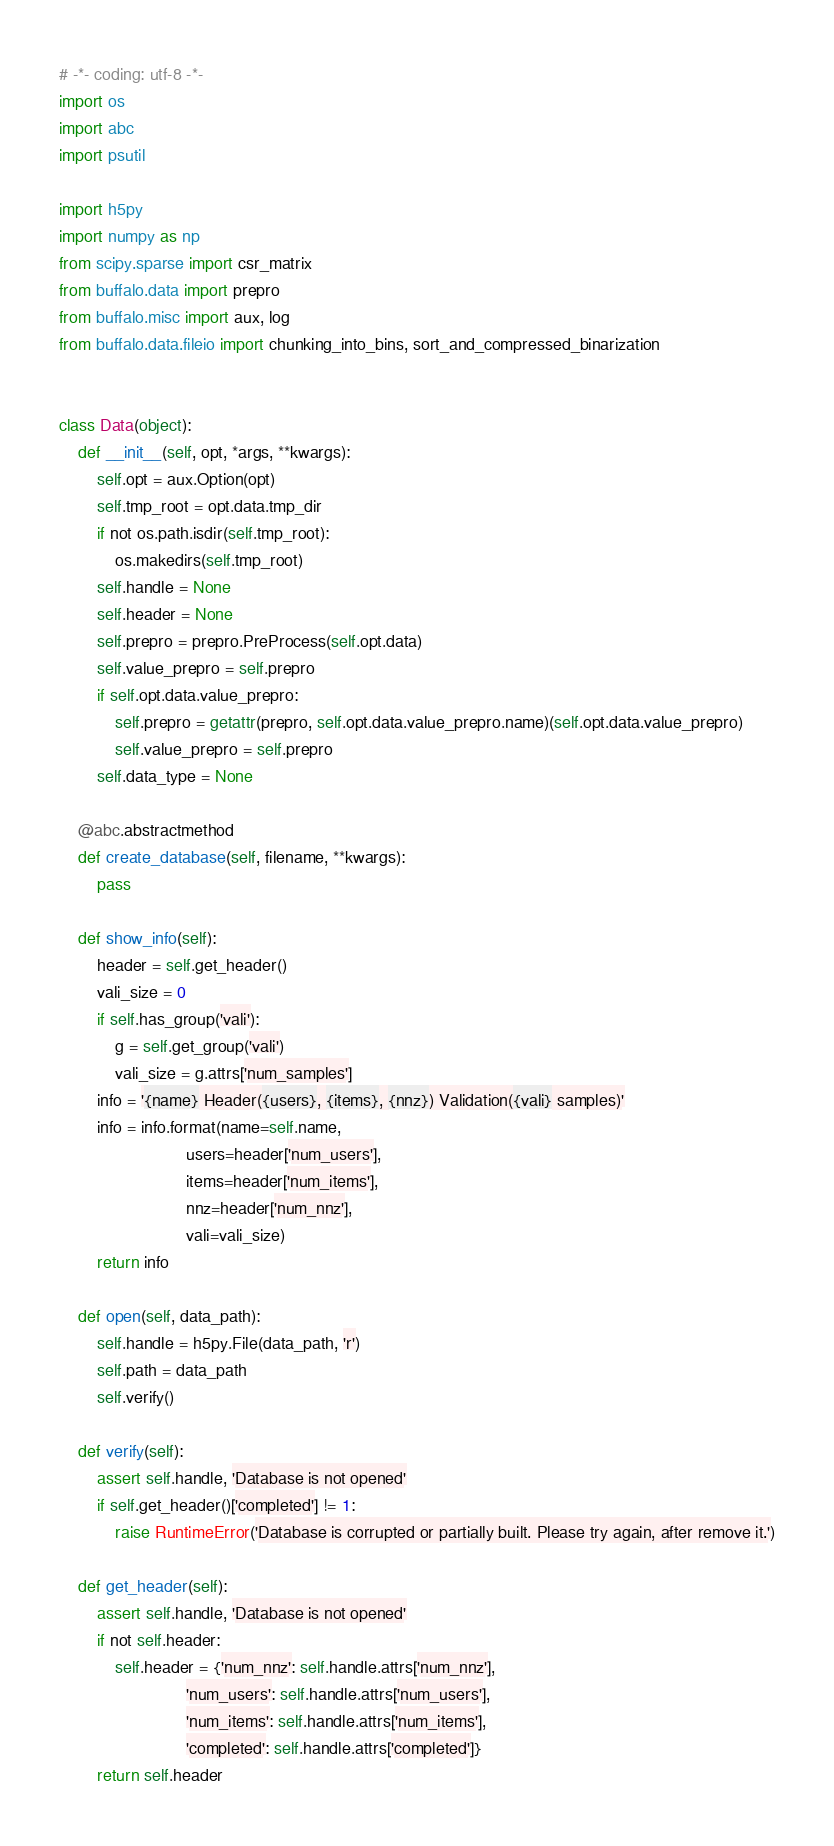<code> <loc_0><loc_0><loc_500><loc_500><_Python_># -*- coding: utf-8 -*-
import os
import abc
import psutil

import h5py
import numpy as np
from scipy.sparse import csr_matrix
from buffalo.data import prepro
from buffalo.misc import aux, log
from buffalo.data.fileio import chunking_into_bins, sort_and_compressed_binarization


class Data(object):
    def __init__(self, opt, *args, **kwargs):
        self.opt = aux.Option(opt)
        self.tmp_root = opt.data.tmp_dir
        if not os.path.isdir(self.tmp_root):
            os.makedirs(self.tmp_root)
        self.handle = None
        self.header = None
        self.prepro = prepro.PreProcess(self.opt.data)
        self.value_prepro = self.prepro
        if self.opt.data.value_prepro:
            self.prepro = getattr(prepro, self.opt.data.value_prepro.name)(self.opt.data.value_prepro)
            self.value_prepro = self.prepro
        self.data_type = None

    @abc.abstractmethod
    def create_database(self, filename, **kwargs):
        pass

    def show_info(self):
        header = self.get_header()
        vali_size = 0
        if self.has_group('vali'):
            g = self.get_group('vali')
            vali_size = g.attrs['num_samples']
        info = '{name} Header({users}, {items}, {nnz}) Validation({vali} samples)'
        info = info.format(name=self.name,
                           users=header['num_users'],
                           items=header['num_items'],
                           nnz=header['num_nnz'],
                           vali=vali_size)
        return info

    def open(self, data_path):
        self.handle = h5py.File(data_path, 'r')
        self.path = data_path
        self.verify()

    def verify(self):
        assert self.handle, 'Database is not opened'
        if self.get_header()['completed'] != 1:
            raise RuntimeError('Database is corrupted or partially built. Please try again, after remove it.')

    def get_header(self):
        assert self.handle, 'Database is not opened'
        if not self.header:
            self.header = {'num_nnz': self.handle.attrs['num_nnz'],
                           'num_users': self.handle.attrs['num_users'],
                           'num_items': self.handle.attrs['num_items'],
                           'completed': self.handle.attrs['completed']}
        return self.header
</code> 